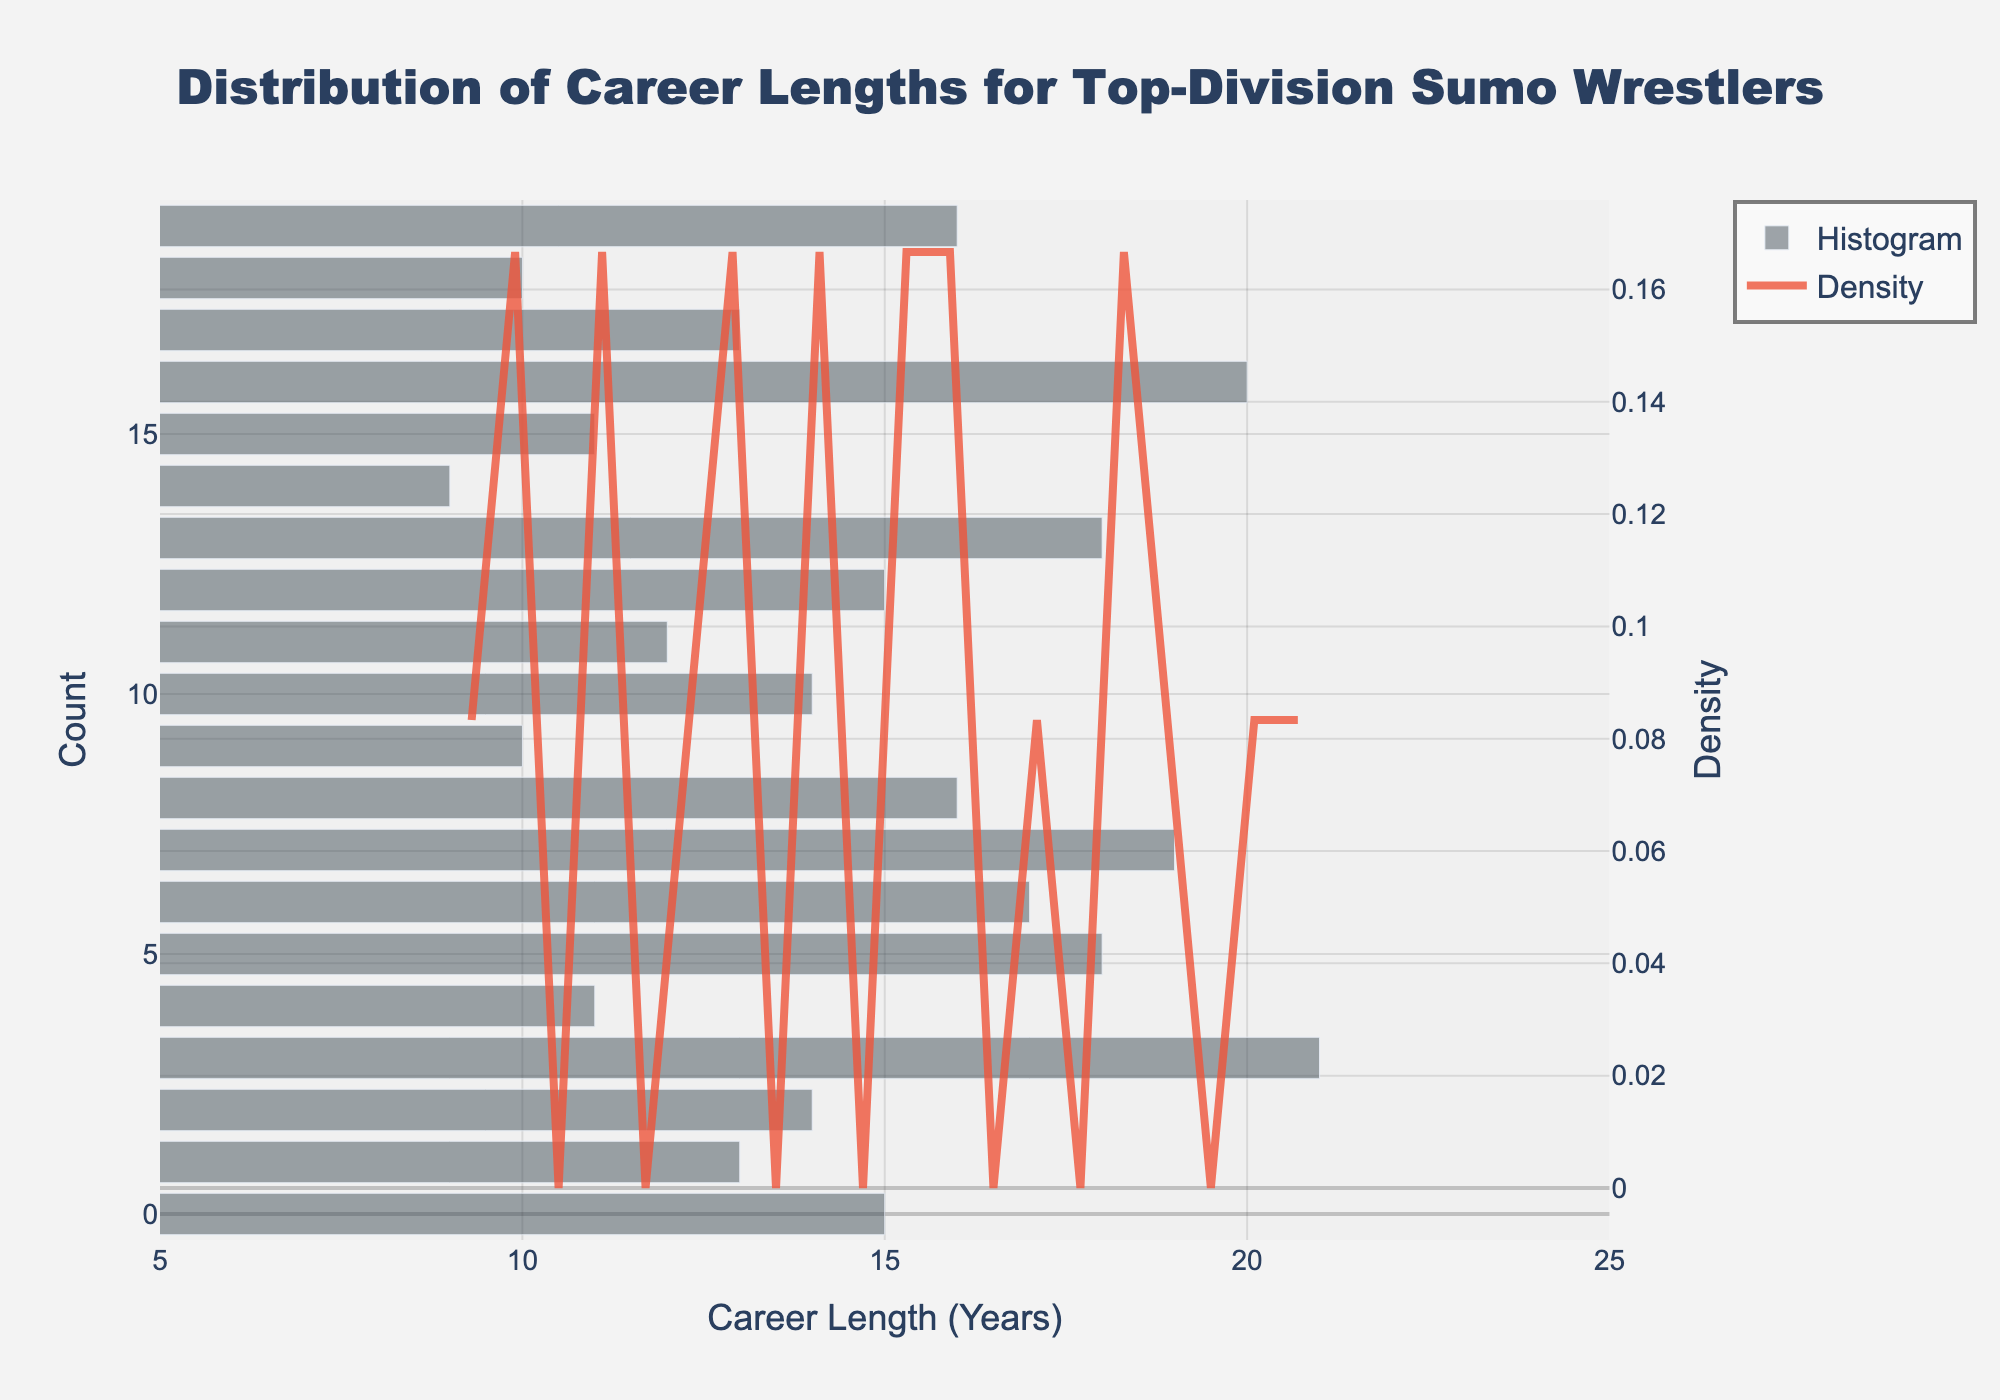What is the title of the figure? The title is usually placed at the top of the figure. In this case, it clearly mentions the topic of the plot.
Answer: Distribution of Career Lengths for Top-Division Sumo Wrestlers What does the x-axis represent? The x-axis label provides information on what this axis measures. Here, it shows the number of years of career length for sumo wrestlers.
Answer: Career Length (Years) How many wrestlers have a career length of 10 years according to the histogram? By looking at the height of the bars in the histogram, we can determine the count for each career length. The bar corresponding to 10 years indicates the count.
Answer: 2 Which wrestler has the longest career length? From the data and corresponding histogram, the wrestler with the maximum career length can be identified as the one with the highest value on the x-axis.
Answer: Chiyonofuji What is the range of the x-axis? The x-axis range is determined by examining the plot visually from the left-most to the right-most point on the x-axis.
Answer: 5 to 25 years What is the peak density value of the KDE curve, and at what career length does it occur? The KDE curve's peak represents the highest density point. By identifying the highest point on the KDE curve and looking down to the x-axis, we find the corresponding career length.
Answer: Approx. 0.06 at 15 years How does the number of wrestlers with career lengths between 15 and 20 years compare to those between 10 and 15 years? We compare the histogram bars within the specified ranges. Count the bars for each range and their heights to compare.
Answer: More wrestlers have career lengths between 15 and 20 years What is the central tendency of career lengths observed from the figure? The central tendency can be deduced by looking at where the histogram and KDE peak, which indicates the most common career lengths.
Answer: Around 15 years How many career lengths are represented more than twice in the histogram? By visually inspecting the histogram bars, count the number of bars that exceed the height representing '2'.
Answer: 11 career lengths 